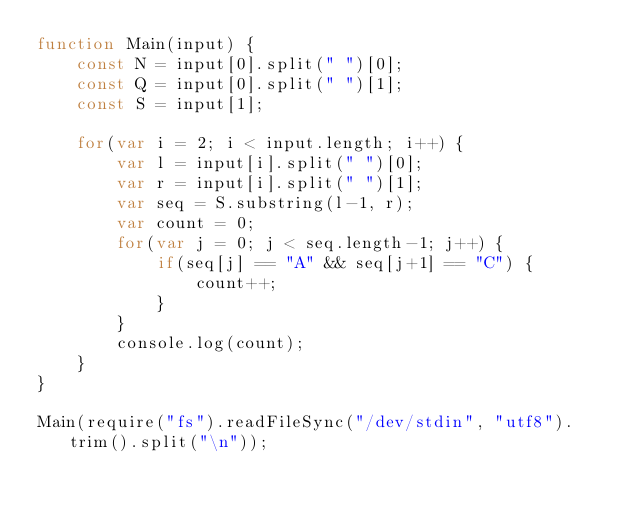Convert code to text. <code><loc_0><loc_0><loc_500><loc_500><_JavaScript_>function Main(input) {
    const N = input[0].split(" ")[0];
    const Q = input[0].split(" ")[1];
    const S = input[1];
    
    for(var i = 2; i < input.length; i++) {
        var l = input[i].split(" ")[0];
        var r = input[i].split(" ")[1];
        var seq = S.substring(l-1, r);
        var count = 0;
        for(var j = 0; j < seq.length-1; j++) {
            if(seq[j] == "A" && seq[j+1] == "C") {
                count++;
            }
        }
        console.log(count);
    }
}

Main(require("fs").readFileSync("/dev/stdin", "utf8").trim().split("\n"));
</code> 